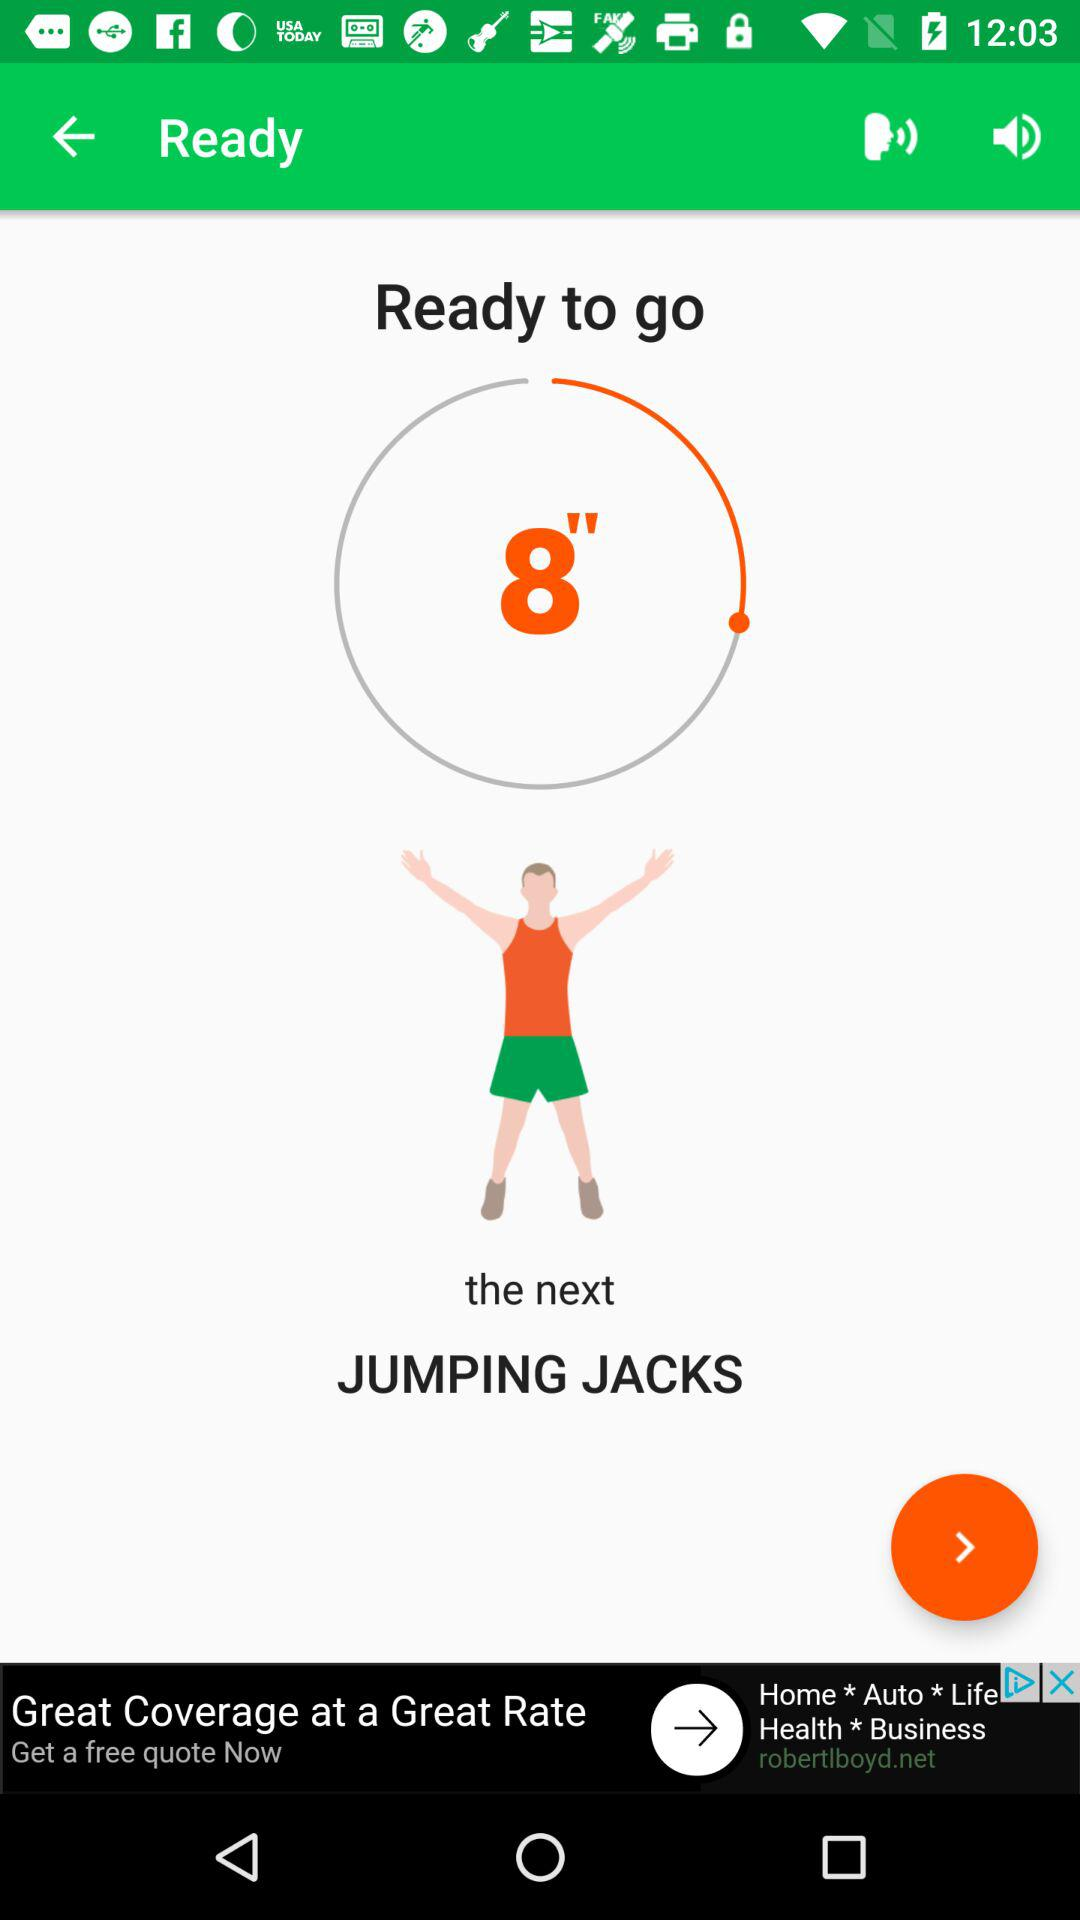What exercise is coming up next in the app? The next exercise displayed on the app is jumping jacks, as indicated by the text and the accompanying illustration of a person doing the exercise. 